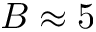Convert formula to latex. <formula><loc_0><loc_0><loc_500><loc_500>B \approx 5</formula> 